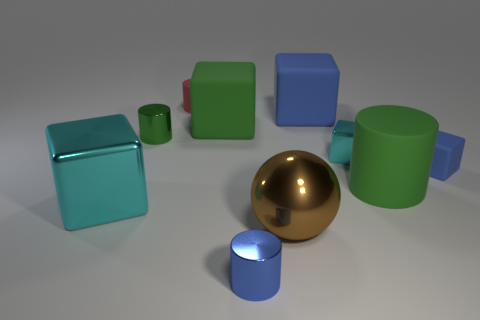Subtract all small metallic blocks. How many blocks are left? 4 Subtract all green cubes. How many cubes are left? 4 Subtract all brown blocks. Subtract all blue balls. How many blocks are left? 5 Subtract all spheres. How many objects are left? 9 Subtract 2 green cylinders. How many objects are left? 8 Subtract all large yellow metallic balls. Subtract all large brown objects. How many objects are left? 9 Add 2 big blue matte cubes. How many big blue matte cubes are left? 3 Add 6 large metallic spheres. How many large metallic spheres exist? 7 